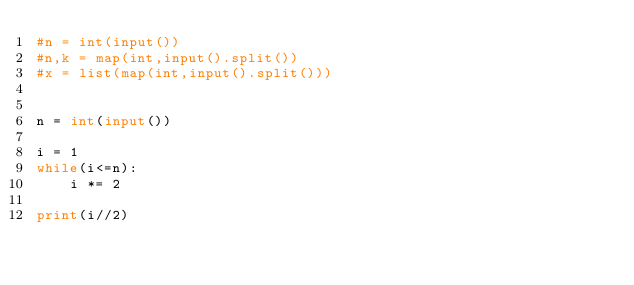<code> <loc_0><loc_0><loc_500><loc_500><_Python_>#n = int(input())
#n,k = map(int,input().split())
#x = list(map(int,input().split()))


n = int(input())

i = 1
while(i<=n):
    i *= 2

print(i//2)
</code> 